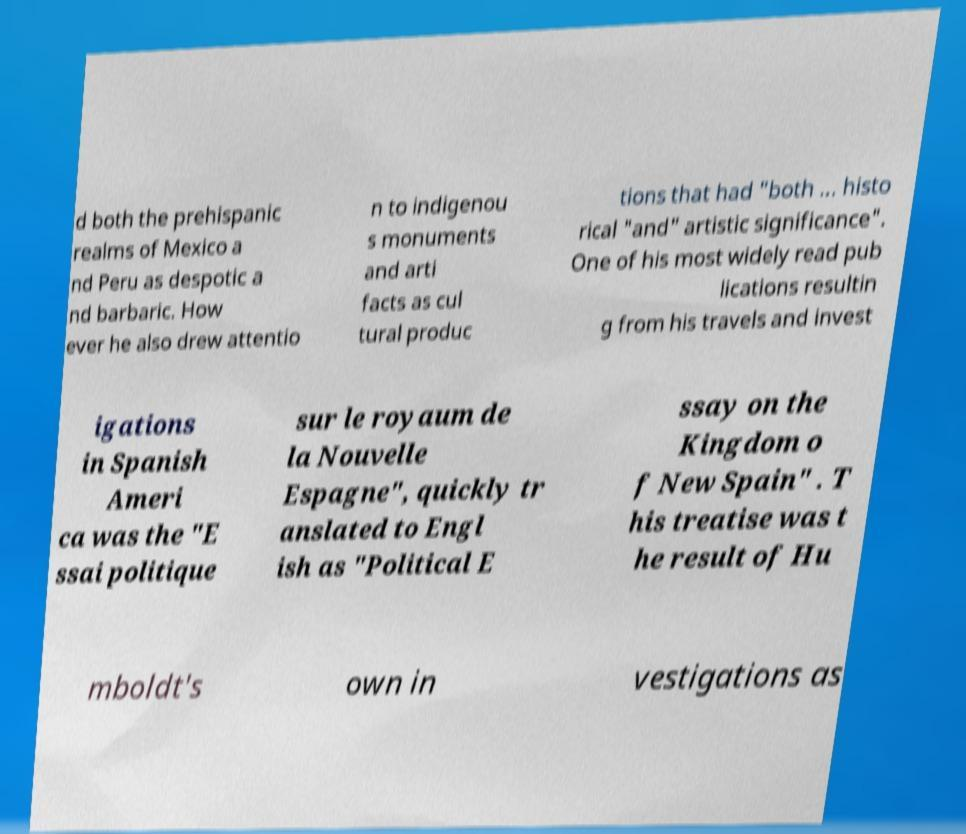There's text embedded in this image that I need extracted. Can you transcribe it verbatim? d both the prehispanic realms of Mexico a nd Peru as despotic a nd barbaric. How ever he also drew attentio n to indigenou s monuments and arti facts as cul tural produc tions that had "both ... histo rical "and" artistic significance". One of his most widely read pub lications resultin g from his travels and invest igations in Spanish Ameri ca was the "E ssai politique sur le royaum de la Nouvelle Espagne", quickly tr anslated to Engl ish as "Political E ssay on the Kingdom o f New Spain" . T his treatise was t he result of Hu mboldt's own in vestigations as 